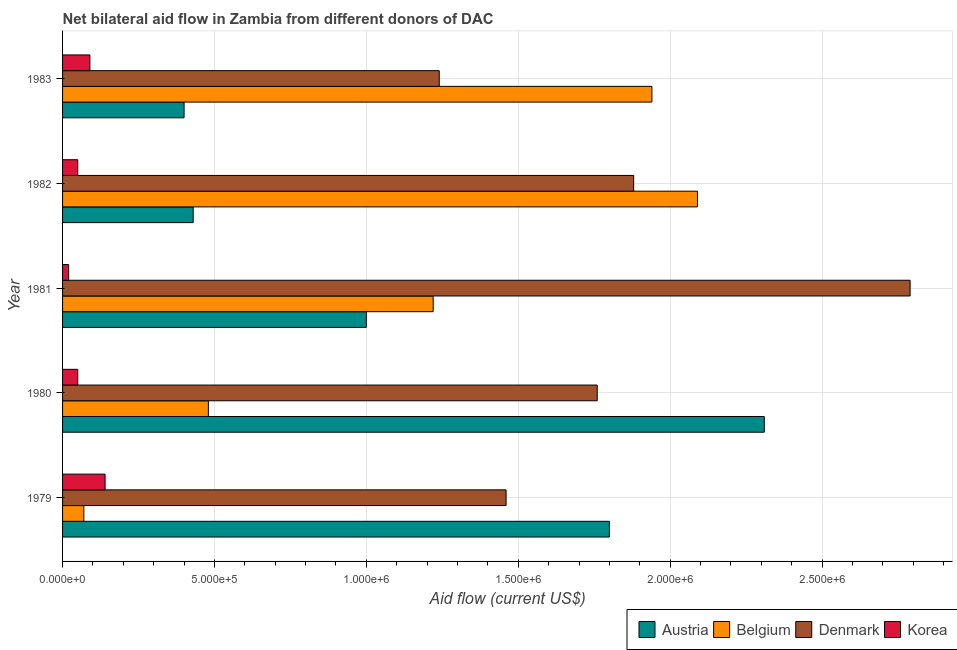How many different coloured bars are there?
Give a very brief answer. 4. Are the number of bars per tick equal to the number of legend labels?
Give a very brief answer. Yes. Are the number of bars on each tick of the Y-axis equal?
Offer a terse response. Yes. How many bars are there on the 2nd tick from the top?
Make the answer very short. 4. How many bars are there on the 5th tick from the bottom?
Make the answer very short. 4. What is the label of the 1st group of bars from the top?
Provide a succinct answer. 1983. What is the amount of aid given by denmark in 1983?
Your response must be concise. 1.24e+06. Across all years, what is the maximum amount of aid given by korea?
Make the answer very short. 1.40e+05. Across all years, what is the minimum amount of aid given by denmark?
Provide a short and direct response. 1.24e+06. In which year was the amount of aid given by korea maximum?
Your answer should be compact. 1979. In which year was the amount of aid given by denmark minimum?
Give a very brief answer. 1983. What is the total amount of aid given by denmark in the graph?
Offer a very short reply. 9.13e+06. What is the difference between the amount of aid given by belgium in 1979 and that in 1981?
Provide a succinct answer. -1.15e+06. What is the difference between the amount of aid given by austria in 1980 and the amount of aid given by korea in 1979?
Offer a terse response. 2.17e+06. What is the average amount of aid given by denmark per year?
Provide a short and direct response. 1.83e+06. In the year 1980, what is the difference between the amount of aid given by belgium and amount of aid given by korea?
Make the answer very short. 4.30e+05. In how many years, is the amount of aid given by belgium greater than 600000 US$?
Provide a short and direct response. 3. What is the ratio of the amount of aid given by korea in 1979 to that in 1981?
Ensure brevity in your answer.  7. Is the amount of aid given by korea in 1979 less than that in 1981?
Offer a very short reply. No. What is the difference between the highest and the second highest amount of aid given by korea?
Make the answer very short. 5.00e+04. What is the difference between the highest and the lowest amount of aid given by belgium?
Provide a succinct answer. 2.02e+06. In how many years, is the amount of aid given by korea greater than the average amount of aid given by korea taken over all years?
Your response must be concise. 2. What does the 2nd bar from the top in 1980 represents?
Make the answer very short. Denmark. What does the 4th bar from the bottom in 1983 represents?
Provide a succinct answer. Korea. How many bars are there?
Offer a very short reply. 20. Are all the bars in the graph horizontal?
Offer a terse response. Yes. What is the difference between two consecutive major ticks on the X-axis?
Your response must be concise. 5.00e+05. Are the values on the major ticks of X-axis written in scientific E-notation?
Provide a succinct answer. Yes. Does the graph contain any zero values?
Offer a terse response. No. Does the graph contain grids?
Your answer should be compact. Yes. Where does the legend appear in the graph?
Offer a very short reply. Bottom right. What is the title of the graph?
Your response must be concise. Net bilateral aid flow in Zambia from different donors of DAC. What is the Aid flow (current US$) in Austria in 1979?
Keep it short and to the point. 1.80e+06. What is the Aid flow (current US$) in Belgium in 1979?
Your answer should be very brief. 7.00e+04. What is the Aid flow (current US$) of Denmark in 1979?
Your answer should be very brief. 1.46e+06. What is the Aid flow (current US$) in Austria in 1980?
Provide a succinct answer. 2.31e+06. What is the Aid flow (current US$) in Belgium in 1980?
Make the answer very short. 4.80e+05. What is the Aid flow (current US$) in Denmark in 1980?
Ensure brevity in your answer.  1.76e+06. What is the Aid flow (current US$) of Korea in 1980?
Make the answer very short. 5.00e+04. What is the Aid flow (current US$) of Belgium in 1981?
Provide a short and direct response. 1.22e+06. What is the Aid flow (current US$) of Denmark in 1981?
Provide a short and direct response. 2.79e+06. What is the Aid flow (current US$) in Korea in 1981?
Provide a short and direct response. 2.00e+04. What is the Aid flow (current US$) in Austria in 1982?
Keep it short and to the point. 4.30e+05. What is the Aid flow (current US$) in Belgium in 1982?
Provide a short and direct response. 2.09e+06. What is the Aid flow (current US$) in Denmark in 1982?
Your answer should be compact. 1.88e+06. What is the Aid flow (current US$) in Korea in 1982?
Your answer should be very brief. 5.00e+04. What is the Aid flow (current US$) in Belgium in 1983?
Offer a very short reply. 1.94e+06. What is the Aid flow (current US$) of Denmark in 1983?
Your answer should be compact. 1.24e+06. Across all years, what is the maximum Aid flow (current US$) in Austria?
Provide a short and direct response. 2.31e+06. Across all years, what is the maximum Aid flow (current US$) of Belgium?
Your answer should be very brief. 2.09e+06. Across all years, what is the maximum Aid flow (current US$) in Denmark?
Ensure brevity in your answer.  2.79e+06. Across all years, what is the maximum Aid flow (current US$) of Korea?
Provide a short and direct response. 1.40e+05. Across all years, what is the minimum Aid flow (current US$) of Austria?
Make the answer very short. 4.00e+05. Across all years, what is the minimum Aid flow (current US$) in Belgium?
Offer a terse response. 7.00e+04. Across all years, what is the minimum Aid flow (current US$) of Denmark?
Make the answer very short. 1.24e+06. Across all years, what is the minimum Aid flow (current US$) of Korea?
Your response must be concise. 2.00e+04. What is the total Aid flow (current US$) of Austria in the graph?
Provide a succinct answer. 5.94e+06. What is the total Aid flow (current US$) of Belgium in the graph?
Give a very brief answer. 5.80e+06. What is the total Aid flow (current US$) in Denmark in the graph?
Offer a very short reply. 9.13e+06. What is the total Aid flow (current US$) of Korea in the graph?
Provide a succinct answer. 3.50e+05. What is the difference between the Aid flow (current US$) of Austria in 1979 and that in 1980?
Ensure brevity in your answer.  -5.10e+05. What is the difference between the Aid flow (current US$) in Belgium in 1979 and that in 1980?
Keep it short and to the point. -4.10e+05. What is the difference between the Aid flow (current US$) of Korea in 1979 and that in 1980?
Your answer should be very brief. 9.00e+04. What is the difference between the Aid flow (current US$) in Austria in 1979 and that in 1981?
Provide a short and direct response. 8.00e+05. What is the difference between the Aid flow (current US$) of Belgium in 1979 and that in 1981?
Make the answer very short. -1.15e+06. What is the difference between the Aid flow (current US$) in Denmark in 1979 and that in 1981?
Your answer should be very brief. -1.33e+06. What is the difference between the Aid flow (current US$) in Austria in 1979 and that in 1982?
Provide a short and direct response. 1.37e+06. What is the difference between the Aid flow (current US$) of Belgium in 1979 and that in 1982?
Give a very brief answer. -2.02e+06. What is the difference between the Aid flow (current US$) of Denmark in 1979 and that in 1982?
Make the answer very short. -4.20e+05. What is the difference between the Aid flow (current US$) in Austria in 1979 and that in 1983?
Offer a very short reply. 1.40e+06. What is the difference between the Aid flow (current US$) in Belgium in 1979 and that in 1983?
Keep it short and to the point. -1.87e+06. What is the difference between the Aid flow (current US$) of Denmark in 1979 and that in 1983?
Your answer should be compact. 2.20e+05. What is the difference between the Aid flow (current US$) in Korea in 1979 and that in 1983?
Offer a terse response. 5.00e+04. What is the difference between the Aid flow (current US$) of Austria in 1980 and that in 1981?
Offer a terse response. 1.31e+06. What is the difference between the Aid flow (current US$) of Belgium in 1980 and that in 1981?
Provide a succinct answer. -7.40e+05. What is the difference between the Aid flow (current US$) in Denmark in 1980 and that in 1981?
Your answer should be very brief. -1.03e+06. What is the difference between the Aid flow (current US$) in Austria in 1980 and that in 1982?
Your response must be concise. 1.88e+06. What is the difference between the Aid flow (current US$) of Belgium in 1980 and that in 1982?
Give a very brief answer. -1.61e+06. What is the difference between the Aid flow (current US$) of Korea in 1980 and that in 1982?
Offer a very short reply. 0. What is the difference between the Aid flow (current US$) of Austria in 1980 and that in 1983?
Make the answer very short. 1.91e+06. What is the difference between the Aid flow (current US$) in Belgium in 1980 and that in 1983?
Offer a very short reply. -1.46e+06. What is the difference between the Aid flow (current US$) in Denmark in 1980 and that in 1983?
Your answer should be compact. 5.20e+05. What is the difference between the Aid flow (current US$) in Austria in 1981 and that in 1982?
Provide a succinct answer. 5.70e+05. What is the difference between the Aid flow (current US$) in Belgium in 1981 and that in 1982?
Give a very brief answer. -8.70e+05. What is the difference between the Aid flow (current US$) of Denmark in 1981 and that in 1982?
Ensure brevity in your answer.  9.10e+05. What is the difference between the Aid flow (current US$) of Korea in 1981 and that in 1982?
Make the answer very short. -3.00e+04. What is the difference between the Aid flow (current US$) of Austria in 1981 and that in 1983?
Offer a very short reply. 6.00e+05. What is the difference between the Aid flow (current US$) of Belgium in 1981 and that in 1983?
Provide a short and direct response. -7.20e+05. What is the difference between the Aid flow (current US$) in Denmark in 1981 and that in 1983?
Provide a short and direct response. 1.55e+06. What is the difference between the Aid flow (current US$) of Korea in 1981 and that in 1983?
Provide a succinct answer. -7.00e+04. What is the difference between the Aid flow (current US$) of Denmark in 1982 and that in 1983?
Keep it short and to the point. 6.40e+05. What is the difference between the Aid flow (current US$) of Korea in 1982 and that in 1983?
Keep it short and to the point. -4.00e+04. What is the difference between the Aid flow (current US$) in Austria in 1979 and the Aid flow (current US$) in Belgium in 1980?
Your answer should be compact. 1.32e+06. What is the difference between the Aid flow (current US$) in Austria in 1979 and the Aid flow (current US$) in Korea in 1980?
Ensure brevity in your answer.  1.75e+06. What is the difference between the Aid flow (current US$) of Belgium in 1979 and the Aid flow (current US$) of Denmark in 1980?
Make the answer very short. -1.69e+06. What is the difference between the Aid flow (current US$) in Denmark in 1979 and the Aid flow (current US$) in Korea in 1980?
Make the answer very short. 1.41e+06. What is the difference between the Aid flow (current US$) of Austria in 1979 and the Aid flow (current US$) of Belgium in 1981?
Offer a terse response. 5.80e+05. What is the difference between the Aid flow (current US$) in Austria in 1979 and the Aid flow (current US$) in Denmark in 1981?
Your response must be concise. -9.90e+05. What is the difference between the Aid flow (current US$) in Austria in 1979 and the Aid flow (current US$) in Korea in 1981?
Ensure brevity in your answer.  1.78e+06. What is the difference between the Aid flow (current US$) in Belgium in 1979 and the Aid flow (current US$) in Denmark in 1981?
Give a very brief answer. -2.72e+06. What is the difference between the Aid flow (current US$) of Denmark in 1979 and the Aid flow (current US$) of Korea in 1981?
Offer a very short reply. 1.44e+06. What is the difference between the Aid flow (current US$) of Austria in 1979 and the Aid flow (current US$) of Denmark in 1982?
Ensure brevity in your answer.  -8.00e+04. What is the difference between the Aid flow (current US$) of Austria in 1979 and the Aid flow (current US$) of Korea in 1982?
Your answer should be very brief. 1.75e+06. What is the difference between the Aid flow (current US$) in Belgium in 1979 and the Aid flow (current US$) in Denmark in 1982?
Offer a terse response. -1.81e+06. What is the difference between the Aid flow (current US$) of Belgium in 1979 and the Aid flow (current US$) of Korea in 1982?
Your answer should be very brief. 2.00e+04. What is the difference between the Aid flow (current US$) in Denmark in 1979 and the Aid flow (current US$) in Korea in 1982?
Offer a very short reply. 1.41e+06. What is the difference between the Aid flow (current US$) of Austria in 1979 and the Aid flow (current US$) of Belgium in 1983?
Your answer should be compact. -1.40e+05. What is the difference between the Aid flow (current US$) of Austria in 1979 and the Aid flow (current US$) of Denmark in 1983?
Keep it short and to the point. 5.60e+05. What is the difference between the Aid flow (current US$) in Austria in 1979 and the Aid flow (current US$) in Korea in 1983?
Your answer should be very brief. 1.71e+06. What is the difference between the Aid flow (current US$) of Belgium in 1979 and the Aid flow (current US$) of Denmark in 1983?
Your answer should be very brief. -1.17e+06. What is the difference between the Aid flow (current US$) of Denmark in 1979 and the Aid flow (current US$) of Korea in 1983?
Ensure brevity in your answer.  1.37e+06. What is the difference between the Aid flow (current US$) in Austria in 1980 and the Aid flow (current US$) in Belgium in 1981?
Your answer should be compact. 1.09e+06. What is the difference between the Aid flow (current US$) of Austria in 1980 and the Aid flow (current US$) of Denmark in 1981?
Your answer should be compact. -4.80e+05. What is the difference between the Aid flow (current US$) in Austria in 1980 and the Aid flow (current US$) in Korea in 1981?
Give a very brief answer. 2.29e+06. What is the difference between the Aid flow (current US$) in Belgium in 1980 and the Aid flow (current US$) in Denmark in 1981?
Offer a terse response. -2.31e+06. What is the difference between the Aid flow (current US$) in Denmark in 1980 and the Aid flow (current US$) in Korea in 1981?
Ensure brevity in your answer.  1.74e+06. What is the difference between the Aid flow (current US$) of Austria in 1980 and the Aid flow (current US$) of Belgium in 1982?
Provide a short and direct response. 2.20e+05. What is the difference between the Aid flow (current US$) in Austria in 1980 and the Aid flow (current US$) in Korea in 1982?
Your answer should be compact. 2.26e+06. What is the difference between the Aid flow (current US$) in Belgium in 1980 and the Aid flow (current US$) in Denmark in 1982?
Your response must be concise. -1.40e+06. What is the difference between the Aid flow (current US$) in Denmark in 1980 and the Aid flow (current US$) in Korea in 1982?
Make the answer very short. 1.71e+06. What is the difference between the Aid flow (current US$) in Austria in 1980 and the Aid flow (current US$) in Belgium in 1983?
Give a very brief answer. 3.70e+05. What is the difference between the Aid flow (current US$) of Austria in 1980 and the Aid flow (current US$) of Denmark in 1983?
Provide a short and direct response. 1.07e+06. What is the difference between the Aid flow (current US$) of Austria in 1980 and the Aid flow (current US$) of Korea in 1983?
Your response must be concise. 2.22e+06. What is the difference between the Aid flow (current US$) of Belgium in 1980 and the Aid flow (current US$) of Denmark in 1983?
Provide a succinct answer. -7.60e+05. What is the difference between the Aid flow (current US$) in Denmark in 1980 and the Aid flow (current US$) in Korea in 1983?
Give a very brief answer. 1.67e+06. What is the difference between the Aid flow (current US$) in Austria in 1981 and the Aid flow (current US$) in Belgium in 1982?
Your response must be concise. -1.09e+06. What is the difference between the Aid flow (current US$) of Austria in 1981 and the Aid flow (current US$) of Denmark in 1982?
Provide a succinct answer. -8.80e+05. What is the difference between the Aid flow (current US$) in Austria in 1981 and the Aid flow (current US$) in Korea in 1982?
Provide a succinct answer. 9.50e+05. What is the difference between the Aid flow (current US$) in Belgium in 1981 and the Aid flow (current US$) in Denmark in 1982?
Provide a short and direct response. -6.60e+05. What is the difference between the Aid flow (current US$) in Belgium in 1981 and the Aid flow (current US$) in Korea in 1982?
Your answer should be compact. 1.17e+06. What is the difference between the Aid flow (current US$) in Denmark in 1981 and the Aid flow (current US$) in Korea in 1982?
Provide a succinct answer. 2.74e+06. What is the difference between the Aid flow (current US$) in Austria in 1981 and the Aid flow (current US$) in Belgium in 1983?
Your answer should be very brief. -9.40e+05. What is the difference between the Aid flow (current US$) of Austria in 1981 and the Aid flow (current US$) of Denmark in 1983?
Provide a short and direct response. -2.40e+05. What is the difference between the Aid flow (current US$) of Austria in 1981 and the Aid flow (current US$) of Korea in 1983?
Ensure brevity in your answer.  9.10e+05. What is the difference between the Aid flow (current US$) in Belgium in 1981 and the Aid flow (current US$) in Denmark in 1983?
Give a very brief answer. -2.00e+04. What is the difference between the Aid flow (current US$) of Belgium in 1981 and the Aid flow (current US$) of Korea in 1983?
Your answer should be compact. 1.13e+06. What is the difference between the Aid flow (current US$) in Denmark in 1981 and the Aid flow (current US$) in Korea in 1983?
Your answer should be compact. 2.70e+06. What is the difference between the Aid flow (current US$) of Austria in 1982 and the Aid flow (current US$) of Belgium in 1983?
Provide a short and direct response. -1.51e+06. What is the difference between the Aid flow (current US$) of Austria in 1982 and the Aid flow (current US$) of Denmark in 1983?
Make the answer very short. -8.10e+05. What is the difference between the Aid flow (current US$) in Belgium in 1982 and the Aid flow (current US$) in Denmark in 1983?
Your answer should be compact. 8.50e+05. What is the difference between the Aid flow (current US$) of Denmark in 1982 and the Aid flow (current US$) of Korea in 1983?
Your answer should be compact. 1.79e+06. What is the average Aid flow (current US$) of Austria per year?
Your answer should be compact. 1.19e+06. What is the average Aid flow (current US$) of Belgium per year?
Your response must be concise. 1.16e+06. What is the average Aid flow (current US$) in Denmark per year?
Make the answer very short. 1.83e+06. What is the average Aid flow (current US$) of Korea per year?
Provide a succinct answer. 7.00e+04. In the year 1979, what is the difference between the Aid flow (current US$) in Austria and Aid flow (current US$) in Belgium?
Give a very brief answer. 1.73e+06. In the year 1979, what is the difference between the Aid flow (current US$) of Austria and Aid flow (current US$) of Korea?
Offer a very short reply. 1.66e+06. In the year 1979, what is the difference between the Aid flow (current US$) in Belgium and Aid flow (current US$) in Denmark?
Offer a very short reply. -1.39e+06. In the year 1979, what is the difference between the Aid flow (current US$) of Denmark and Aid flow (current US$) of Korea?
Ensure brevity in your answer.  1.32e+06. In the year 1980, what is the difference between the Aid flow (current US$) of Austria and Aid flow (current US$) of Belgium?
Your response must be concise. 1.83e+06. In the year 1980, what is the difference between the Aid flow (current US$) of Austria and Aid flow (current US$) of Denmark?
Give a very brief answer. 5.50e+05. In the year 1980, what is the difference between the Aid flow (current US$) in Austria and Aid flow (current US$) in Korea?
Make the answer very short. 2.26e+06. In the year 1980, what is the difference between the Aid flow (current US$) in Belgium and Aid flow (current US$) in Denmark?
Make the answer very short. -1.28e+06. In the year 1980, what is the difference between the Aid flow (current US$) of Denmark and Aid flow (current US$) of Korea?
Offer a terse response. 1.71e+06. In the year 1981, what is the difference between the Aid flow (current US$) of Austria and Aid flow (current US$) of Belgium?
Ensure brevity in your answer.  -2.20e+05. In the year 1981, what is the difference between the Aid flow (current US$) in Austria and Aid flow (current US$) in Denmark?
Provide a short and direct response. -1.79e+06. In the year 1981, what is the difference between the Aid flow (current US$) in Austria and Aid flow (current US$) in Korea?
Your answer should be very brief. 9.80e+05. In the year 1981, what is the difference between the Aid flow (current US$) of Belgium and Aid flow (current US$) of Denmark?
Keep it short and to the point. -1.57e+06. In the year 1981, what is the difference between the Aid flow (current US$) of Belgium and Aid flow (current US$) of Korea?
Your response must be concise. 1.20e+06. In the year 1981, what is the difference between the Aid flow (current US$) in Denmark and Aid flow (current US$) in Korea?
Offer a terse response. 2.77e+06. In the year 1982, what is the difference between the Aid flow (current US$) in Austria and Aid flow (current US$) in Belgium?
Offer a terse response. -1.66e+06. In the year 1982, what is the difference between the Aid flow (current US$) of Austria and Aid flow (current US$) of Denmark?
Your answer should be very brief. -1.45e+06. In the year 1982, what is the difference between the Aid flow (current US$) of Austria and Aid flow (current US$) of Korea?
Make the answer very short. 3.80e+05. In the year 1982, what is the difference between the Aid flow (current US$) in Belgium and Aid flow (current US$) in Korea?
Offer a very short reply. 2.04e+06. In the year 1982, what is the difference between the Aid flow (current US$) of Denmark and Aid flow (current US$) of Korea?
Offer a very short reply. 1.83e+06. In the year 1983, what is the difference between the Aid flow (current US$) in Austria and Aid flow (current US$) in Belgium?
Give a very brief answer. -1.54e+06. In the year 1983, what is the difference between the Aid flow (current US$) in Austria and Aid flow (current US$) in Denmark?
Provide a succinct answer. -8.40e+05. In the year 1983, what is the difference between the Aid flow (current US$) of Belgium and Aid flow (current US$) of Korea?
Your response must be concise. 1.85e+06. In the year 1983, what is the difference between the Aid flow (current US$) in Denmark and Aid flow (current US$) in Korea?
Your answer should be compact. 1.15e+06. What is the ratio of the Aid flow (current US$) in Austria in 1979 to that in 1980?
Keep it short and to the point. 0.78. What is the ratio of the Aid flow (current US$) in Belgium in 1979 to that in 1980?
Give a very brief answer. 0.15. What is the ratio of the Aid flow (current US$) of Denmark in 1979 to that in 1980?
Your answer should be compact. 0.83. What is the ratio of the Aid flow (current US$) of Belgium in 1979 to that in 1981?
Offer a very short reply. 0.06. What is the ratio of the Aid flow (current US$) in Denmark in 1979 to that in 1981?
Your answer should be very brief. 0.52. What is the ratio of the Aid flow (current US$) of Austria in 1979 to that in 1982?
Offer a terse response. 4.19. What is the ratio of the Aid flow (current US$) in Belgium in 1979 to that in 1982?
Provide a succinct answer. 0.03. What is the ratio of the Aid flow (current US$) in Denmark in 1979 to that in 1982?
Offer a terse response. 0.78. What is the ratio of the Aid flow (current US$) in Austria in 1979 to that in 1983?
Your answer should be very brief. 4.5. What is the ratio of the Aid flow (current US$) in Belgium in 1979 to that in 1983?
Keep it short and to the point. 0.04. What is the ratio of the Aid flow (current US$) of Denmark in 1979 to that in 1983?
Offer a very short reply. 1.18. What is the ratio of the Aid flow (current US$) in Korea in 1979 to that in 1983?
Your answer should be compact. 1.56. What is the ratio of the Aid flow (current US$) of Austria in 1980 to that in 1981?
Ensure brevity in your answer.  2.31. What is the ratio of the Aid flow (current US$) of Belgium in 1980 to that in 1981?
Offer a terse response. 0.39. What is the ratio of the Aid flow (current US$) in Denmark in 1980 to that in 1981?
Your response must be concise. 0.63. What is the ratio of the Aid flow (current US$) of Korea in 1980 to that in 1981?
Offer a terse response. 2.5. What is the ratio of the Aid flow (current US$) of Austria in 1980 to that in 1982?
Your answer should be compact. 5.37. What is the ratio of the Aid flow (current US$) of Belgium in 1980 to that in 1982?
Offer a terse response. 0.23. What is the ratio of the Aid flow (current US$) of Denmark in 1980 to that in 1982?
Offer a very short reply. 0.94. What is the ratio of the Aid flow (current US$) of Korea in 1980 to that in 1982?
Keep it short and to the point. 1. What is the ratio of the Aid flow (current US$) of Austria in 1980 to that in 1983?
Your answer should be compact. 5.78. What is the ratio of the Aid flow (current US$) in Belgium in 1980 to that in 1983?
Offer a very short reply. 0.25. What is the ratio of the Aid flow (current US$) in Denmark in 1980 to that in 1983?
Make the answer very short. 1.42. What is the ratio of the Aid flow (current US$) of Korea in 1980 to that in 1983?
Ensure brevity in your answer.  0.56. What is the ratio of the Aid flow (current US$) of Austria in 1981 to that in 1982?
Provide a short and direct response. 2.33. What is the ratio of the Aid flow (current US$) of Belgium in 1981 to that in 1982?
Ensure brevity in your answer.  0.58. What is the ratio of the Aid flow (current US$) of Denmark in 1981 to that in 1982?
Give a very brief answer. 1.48. What is the ratio of the Aid flow (current US$) in Austria in 1981 to that in 1983?
Make the answer very short. 2.5. What is the ratio of the Aid flow (current US$) of Belgium in 1981 to that in 1983?
Make the answer very short. 0.63. What is the ratio of the Aid flow (current US$) in Denmark in 1981 to that in 1983?
Make the answer very short. 2.25. What is the ratio of the Aid flow (current US$) in Korea in 1981 to that in 1983?
Keep it short and to the point. 0.22. What is the ratio of the Aid flow (current US$) of Austria in 1982 to that in 1983?
Give a very brief answer. 1.07. What is the ratio of the Aid flow (current US$) of Belgium in 1982 to that in 1983?
Provide a short and direct response. 1.08. What is the ratio of the Aid flow (current US$) in Denmark in 1982 to that in 1983?
Ensure brevity in your answer.  1.52. What is the ratio of the Aid flow (current US$) of Korea in 1982 to that in 1983?
Keep it short and to the point. 0.56. What is the difference between the highest and the second highest Aid flow (current US$) in Austria?
Your answer should be compact. 5.10e+05. What is the difference between the highest and the second highest Aid flow (current US$) of Denmark?
Give a very brief answer. 9.10e+05. What is the difference between the highest and the lowest Aid flow (current US$) of Austria?
Offer a very short reply. 1.91e+06. What is the difference between the highest and the lowest Aid flow (current US$) in Belgium?
Offer a very short reply. 2.02e+06. What is the difference between the highest and the lowest Aid flow (current US$) of Denmark?
Offer a terse response. 1.55e+06. 